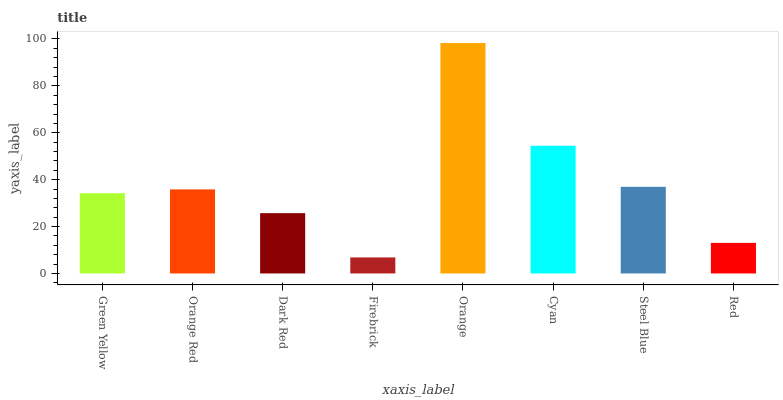Is Firebrick the minimum?
Answer yes or no. Yes. Is Orange the maximum?
Answer yes or no. Yes. Is Orange Red the minimum?
Answer yes or no. No. Is Orange Red the maximum?
Answer yes or no. No. Is Orange Red greater than Green Yellow?
Answer yes or no. Yes. Is Green Yellow less than Orange Red?
Answer yes or no. Yes. Is Green Yellow greater than Orange Red?
Answer yes or no. No. Is Orange Red less than Green Yellow?
Answer yes or no. No. Is Orange Red the high median?
Answer yes or no. Yes. Is Green Yellow the low median?
Answer yes or no. Yes. Is Firebrick the high median?
Answer yes or no. No. Is Orange the low median?
Answer yes or no. No. 